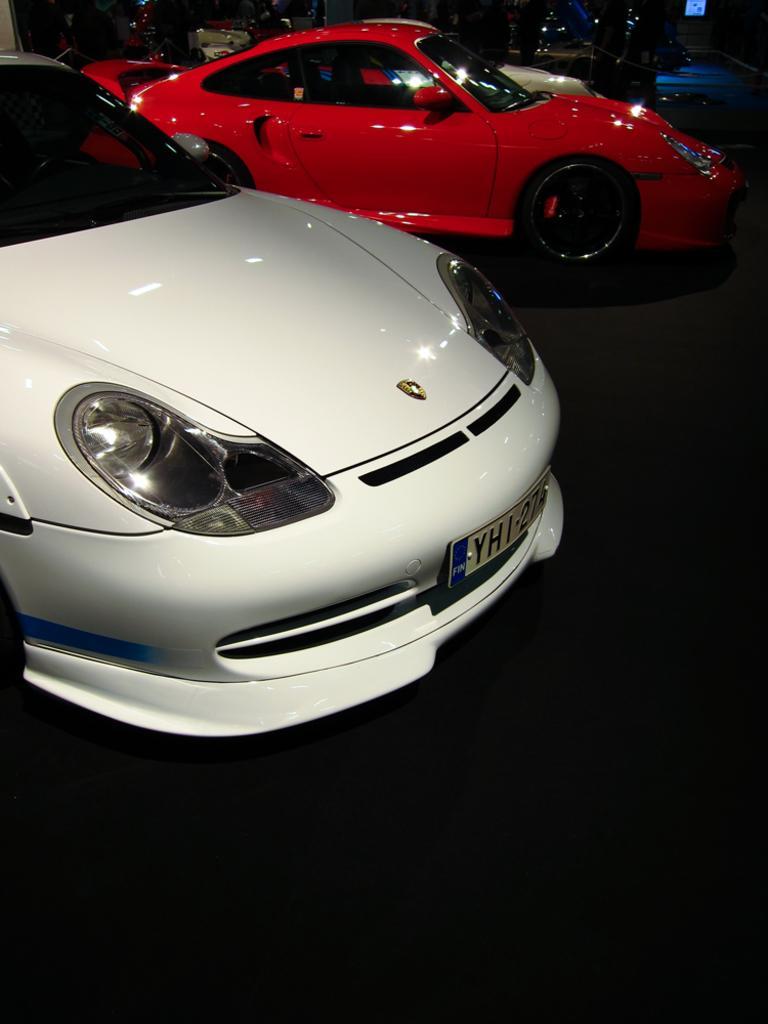How would you summarize this image in a sentence or two? In this picture we can see white and red cars on the floor. Background portion of the picture is dark. 